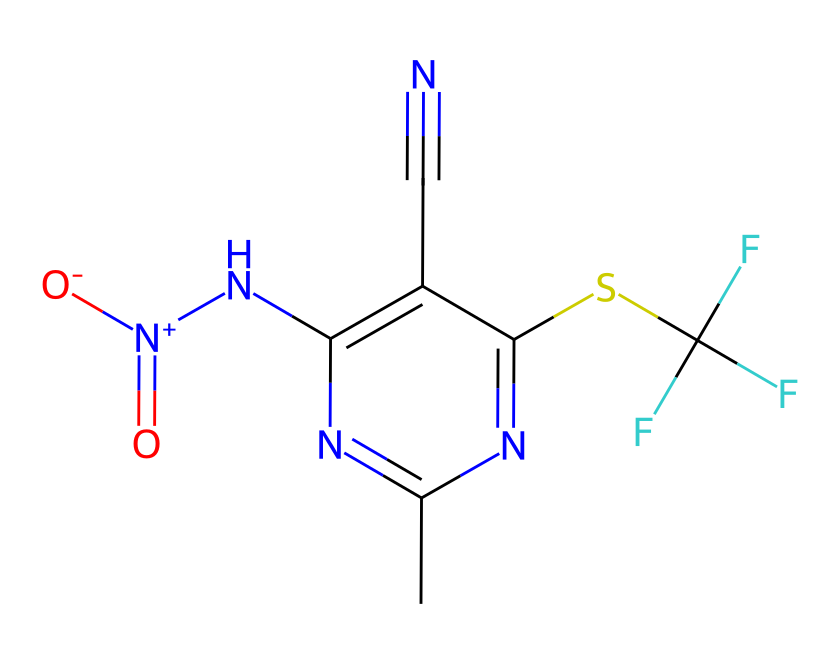What is the primary functional group present in fipronil? The presence of the sulfonyl group, represented by the sulfur (S) bonded to oxygen (O) in the structure, indicates that it has a sulfonamide functional group, which is significant in its insecticidal properties.
Answer: sulfonamide How many carbon atoms are there in fipronil? By counting the carbon atoms represented in the structure, there are a total of 9 carbon atoms present.
Answer: 9 What type of chemical bond is represented by the nitrogen atoms in fipronil? The nitrogen atoms are involved in both single and double bonds with other atoms in the structure, showcasing their varied bonding which includes coordination and resonance as indicated by the multiple nitrogen forms including the quaternary ammonium group.
Answer: multiple bonds How many fluorine atoms are in the structure of fipronil? The structure contains three fluorine atoms which are denoted by the (F) symbols within the chemical representation.
Answer: 3 What aspect of fipronil contributes to its neurotoxic effects? The presence of the nitro group (N[N+](=O)[O-]) in fipronil plays a critical role as it can interfere with neurotransmitter systems, enhancing neurotoxic effects seen in its pesticide function.
Answer: nitro group Which element in fipronil is responsible for its biocidal properties? The sulfur atom in the sulfonyl group is crucial for its interaction with biological systems, contributing to its efficacy as a pesticide by disrupting insect metabolism.
Answer: sulfur What molecular shape is suggested by the arrangement of carbon and nitrogen in fipronil? The arrangement of carbon and nitrogen atoms in fipronil suggests a planar structure primarily due to the presence of double bonds which restrict rotation and establish a fixed geometry.
Answer: planar structure 